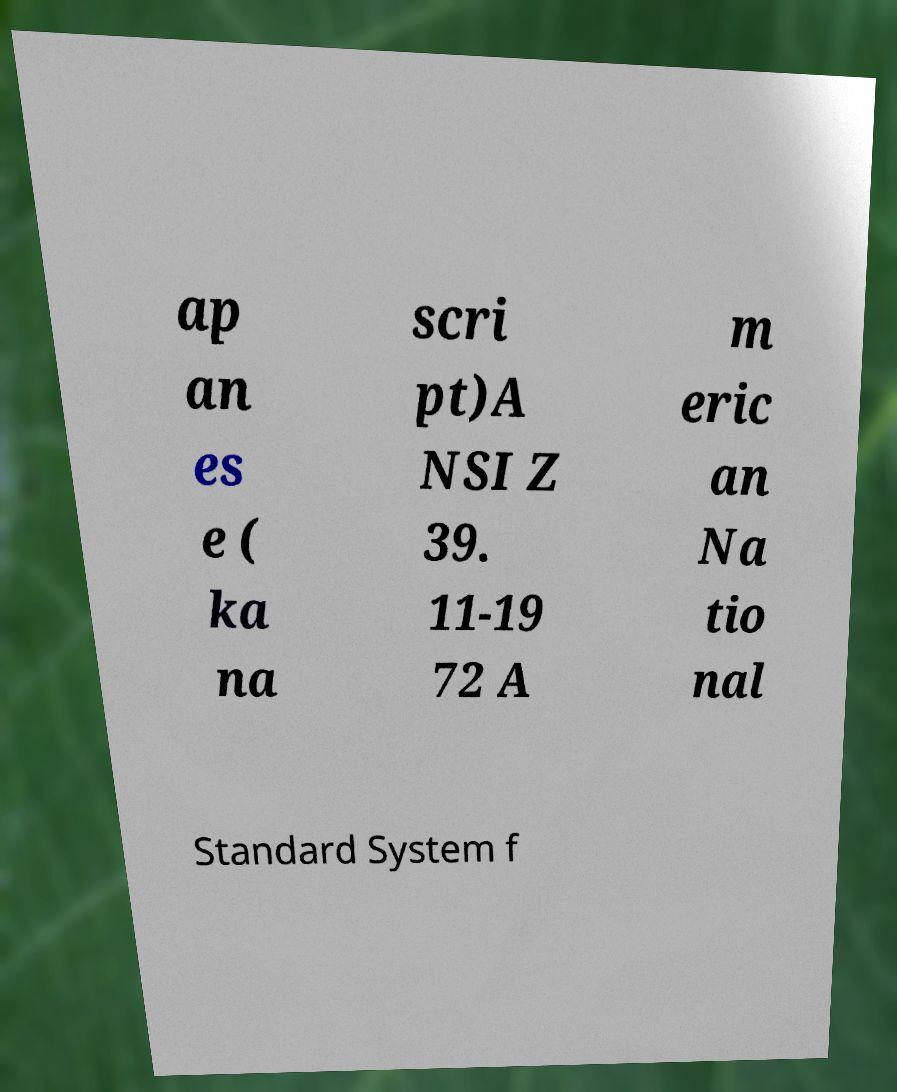Please identify and transcribe the text found in this image. ap an es e ( ka na scri pt)A NSI Z 39. 11-19 72 A m eric an Na tio nal Standard System f 